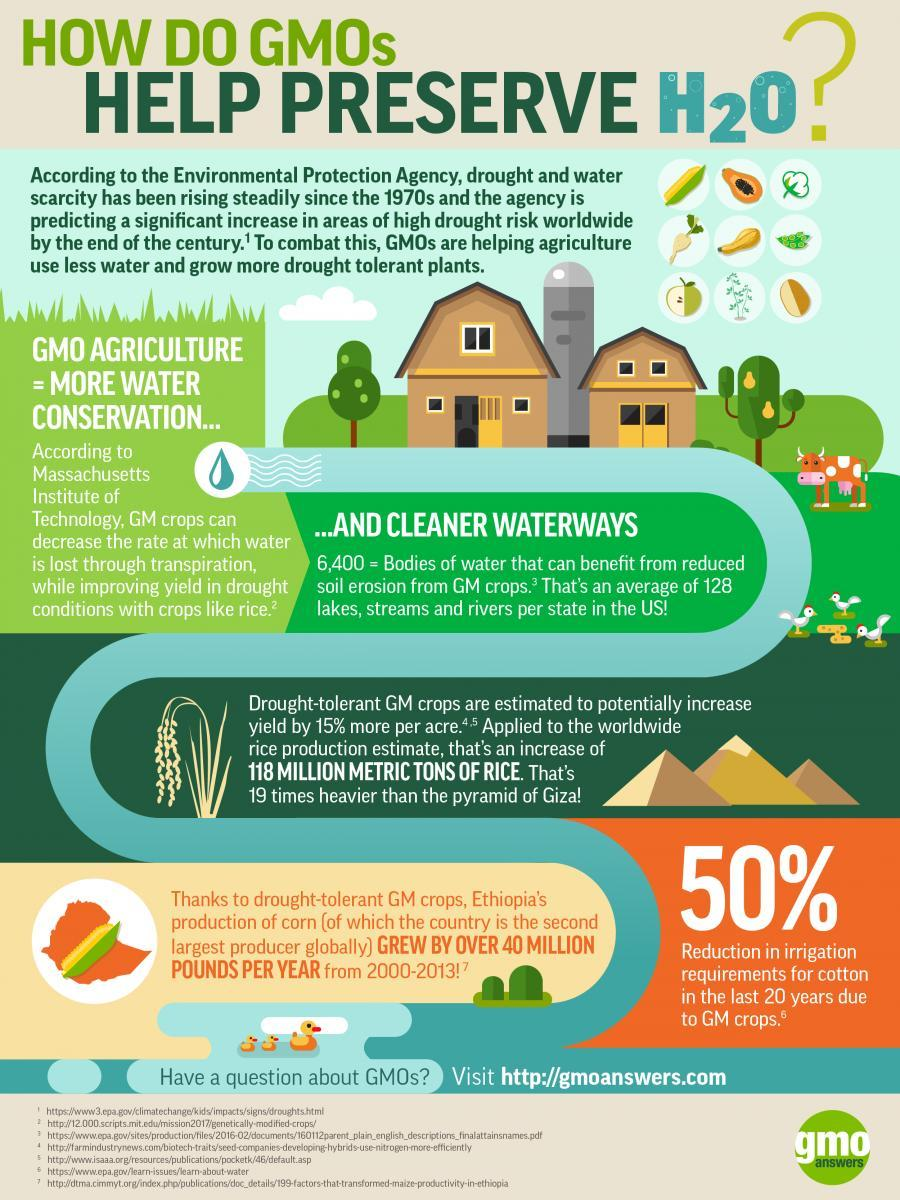Who is the second largest producer of corn
Answer the question with a short phrase. Ethiopia What can lead to more H2O conservation GMO agriculture What is the acronym for Genetically Modified Organisms GMO What is the chemical formula for water H2O 